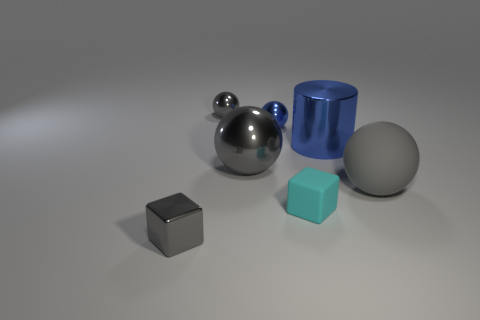Is there anything else of the same color as the tiny matte object?
Provide a succinct answer. No. Does the gray sphere behind the large blue object have the same material as the gray block?
Keep it short and to the point. Yes. Are there the same number of gray objects that are in front of the rubber block and small shiny spheres behind the small blue object?
Your answer should be very brief. Yes. There is a metallic object to the left of the small gray shiny thing that is right of the tiny metal cube; what is its size?
Make the answer very short. Small. What material is the object that is behind the large gray metal ball and on the right side of the tiny blue shiny object?
Your answer should be very brief. Metal. What number of other objects are the same size as the blue cylinder?
Keep it short and to the point. 2. The small rubber thing has what color?
Provide a short and direct response. Cyan. Is the color of the big ball behind the large matte sphere the same as the block that is left of the blue shiny ball?
Provide a short and direct response. Yes. What size is the cyan thing?
Give a very brief answer. Small. There is a gray metal ball behind the small blue metal ball; how big is it?
Give a very brief answer. Small. 